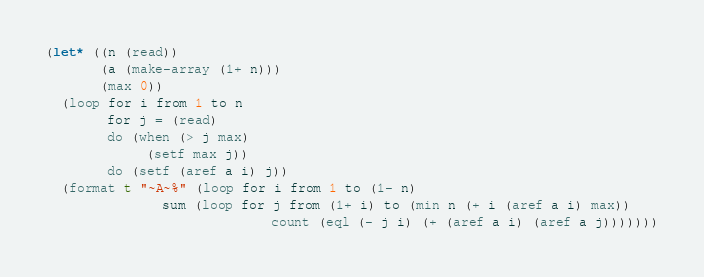Convert code to text. <code><loc_0><loc_0><loc_500><loc_500><_Lisp_>(let* ((n (read))
       (a (make-array (1+ n)))
       (max 0))
  (loop for i from 1 to n
        for j = (read)
        do (when (> j max)
             (setf max j))
        do (setf (aref a i) j))
  (format t "~A~%" (loop for i from 1 to (1- n)
               sum (loop for j from (1+ i) to (min n (+ i (aref a i) max))
                             count (eql (- j i) (+ (aref a i) (aref a j)))))))</code> 